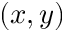<formula> <loc_0><loc_0><loc_500><loc_500>( x , y )</formula> 